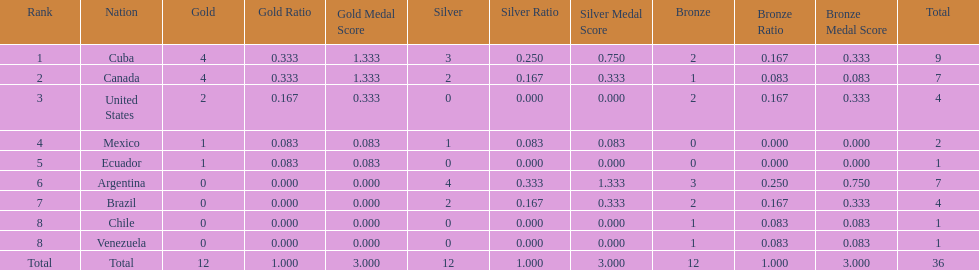Which country won the largest haul of bronze medals? Argentina. 